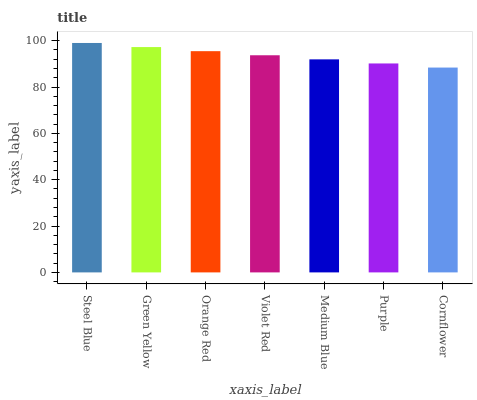Is Cornflower the minimum?
Answer yes or no. Yes. Is Steel Blue the maximum?
Answer yes or no. Yes. Is Green Yellow the minimum?
Answer yes or no. No. Is Green Yellow the maximum?
Answer yes or no. No. Is Steel Blue greater than Green Yellow?
Answer yes or no. Yes. Is Green Yellow less than Steel Blue?
Answer yes or no. Yes. Is Green Yellow greater than Steel Blue?
Answer yes or no. No. Is Steel Blue less than Green Yellow?
Answer yes or no. No. Is Violet Red the high median?
Answer yes or no. Yes. Is Violet Red the low median?
Answer yes or no. Yes. Is Medium Blue the high median?
Answer yes or no. No. Is Orange Red the low median?
Answer yes or no. No. 